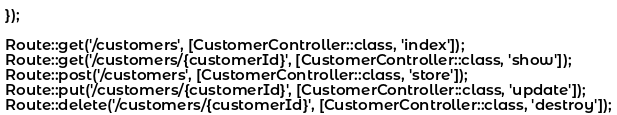<code> <loc_0><loc_0><loc_500><loc_500><_PHP_>});

Route::get('/customers', [CustomerController::class, 'index']);
Route::get('/customers/{customerId}', [CustomerController::class, 'show']);
Route::post('/customers', [CustomerController::class, 'store']);
Route::put('/customers/{customerId}', [CustomerController::class, 'update']);
Route::delete('/customers/{customerId}', [CustomerController::class, 'destroy']);
</code> 